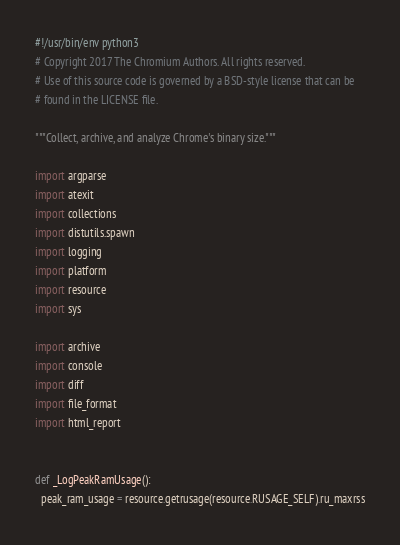<code> <loc_0><loc_0><loc_500><loc_500><_Python_>#!/usr/bin/env python3
# Copyright 2017 The Chromium Authors. All rights reserved.
# Use of this source code is governed by a BSD-style license that can be
# found in the LICENSE file.

"""Collect, archive, and analyze Chrome's binary size."""

import argparse
import atexit
import collections
import distutils.spawn
import logging
import platform
import resource
import sys

import archive
import console
import diff
import file_format
import html_report


def _LogPeakRamUsage():
  peak_ram_usage = resource.getrusage(resource.RUSAGE_SELF).ru_maxrss</code> 